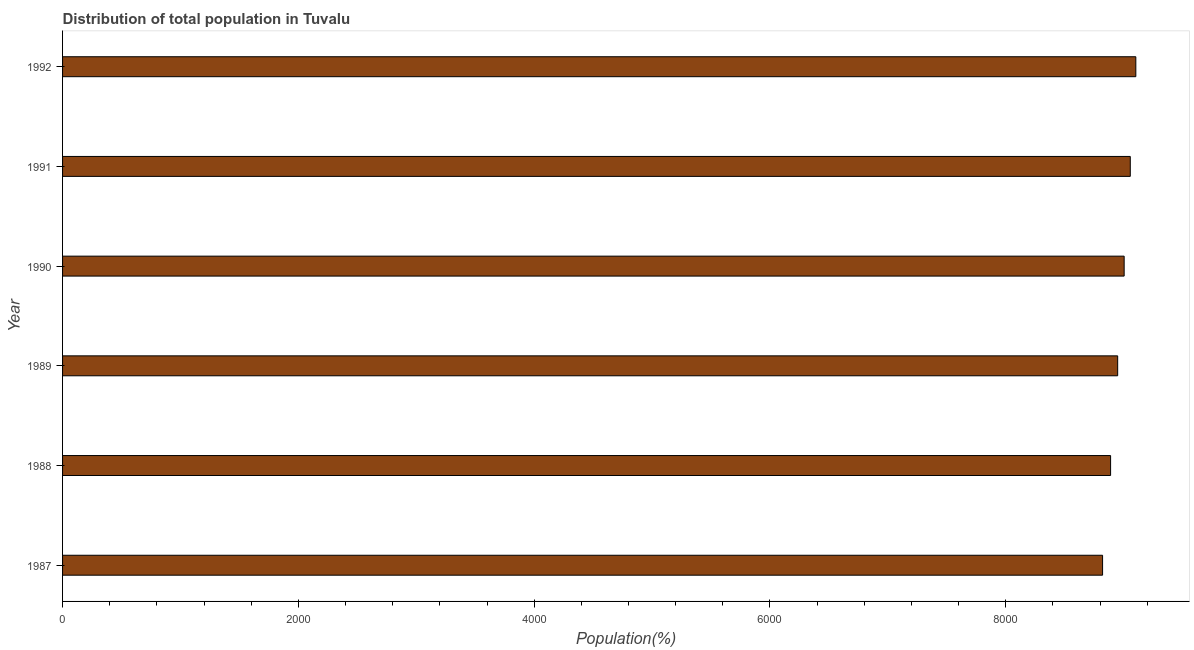What is the title of the graph?
Ensure brevity in your answer.  Distribution of total population in Tuvalu . What is the label or title of the X-axis?
Provide a succinct answer. Population(%). What is the population in 1988?
Your answer should be compact. 8889. Across all years, what is the maximum population?
Keep it short and to the point. 9103. Across all years, what is the minimum population?
Make the answer very short. 8821. What is the sum of the population?
Make the answer very short. 5.38e+04. What is the difference between the population in 1988 and 1991?
Your answer should be very brief. -167. What is the average population per year?
Provide a short and direct response. 8970. What is the median population?
Your response must be concise. 8976.5. What is the difference between the highest and the second highest population?
Your answer should be very brief. 47. What is the difference between the highest and the lowest population?
Offer a terse response. 282. How many years are there in the graph?
Your answer should be compact. 6. Are the values on the major ticks of X-axis written in scientific E-notation?
Provide a short and direct response. No. What is the Population(%) in 1987?
Your answer should be very brief. 8821. What is the Population(%) of 1988?
Your answer should be compact. 8889. What is the Population(%) in 1989?
Keep it short and to the point. 8949. What is the Population(%) of 1990?
Keep it short and to the point. 9004. What is the Population(%) in 1991?
Provide a succinct answer. 9056. What is the Population(%) of 1992?
Offer a very short reply. 9103. What is the difference between the Population(%) in 1987 and 1988?
Give a very brief answer. -68. What is the difference between the Population(%) in 1987 and 1989?
Keep it short and to the point. -128. What is the difference between the Population(%) in 1987 and 1990?
Keep it short and to the point. -183. What is the difference between the Population(%) in 1987 and 1991?
Make the answer very short. -235. What is the difference between the Population(%) in 1987 and 1992?
Make the answer very short. -282. What is the difference between the Population(%) in 1988 and 1989?
Your answer should be very brief. -60. What is the difference between the Population(%) in 1988 and 1990?
Your response must be concise. -115. What is the difference between the Population(%) in 1988 and 1991?
Make the answer very short. -167. What is the difference between the Population(%) in 1988 and 1992?
Make the answer very short. -214. What is the difference between the Population(%) in 1989 and 1990?
Provide a succinct answer. -55. What is the difference between the Population(%) in 1989 and 1991?
Provide a short and direct response. -107. What is the difference between the Population(%) in 1989 and 1992?
Keep it short and to the point. -154. What is the difference between the Population(%) in 1990 and 1991?
Offer a very short reply. -52. What is the difference between the Population(%) in 1990 and 1992?
Provide a short and direct response. -99. What is the difference between the Population(%) in 1991 and 1992?
Your response must be concise. -47. What is the ratio of the Population(%) in 1987 to that in 1990?
Offer a very short reply. 0.98. What is the ratio of the Population(%) in 1987 to that in 1992?
Keep it short and to the point. 0.97. What is the ratio of the Population(%) in 1988 to that in 1990?
Give a very brief answer. 0.99. What is the ratio of the Population(%) in 1988 to that in 1992?
Offer a very short reply. 0.98. What is the ratio of the Population(%) in 1989 to that in 1990?
Provide a short and direct response. 0.99. What is the ratio of the Population(%) in 1989 to that in 1992?
Provide a short and direct response. 0.98. What is the ratio of the Population(%) in 1991 to that in 1992?
Give a very brief answer. 0.99. 